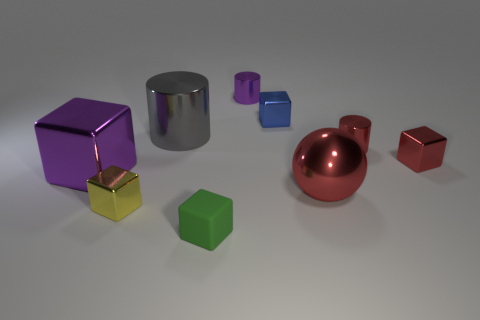Is the shape of the small metallic thing that is in front of the big red metal object the same as the purple object that is on the left side of the small green cube?
Keep it short and to the point. Yes. Do the blue object and the small purple metal object have the same shape?
Give a very brief answer. No. The rubber object is what color?
Provide a short and direct response. Green. What number of things are either red metal cubes or large gray objects?
Keep it short and to the point. 2. Is there anything else that is made of the same material as the green block?
Your answer should be very brief. No. Are there fewer tiny blue cubes that are in front of the large red shiny sphere than yellow things?
Offer a very short reply. Yes. Is the number of small shiny cylinders that are in front of the large cylinder greater than the number of small blue metallic blocks in front of the small yellow shiny object?
Make the answer very short. Yes. Are there any other things that have the same color as the metallic ball?
Provide a succinct answer. Yes. What is the material of the cylinder right of the tiny purple cylinder?
Your answer should be compact. Metal. Is the size of the matte block the same as the red block?
Give a very brief answer. Yes. 